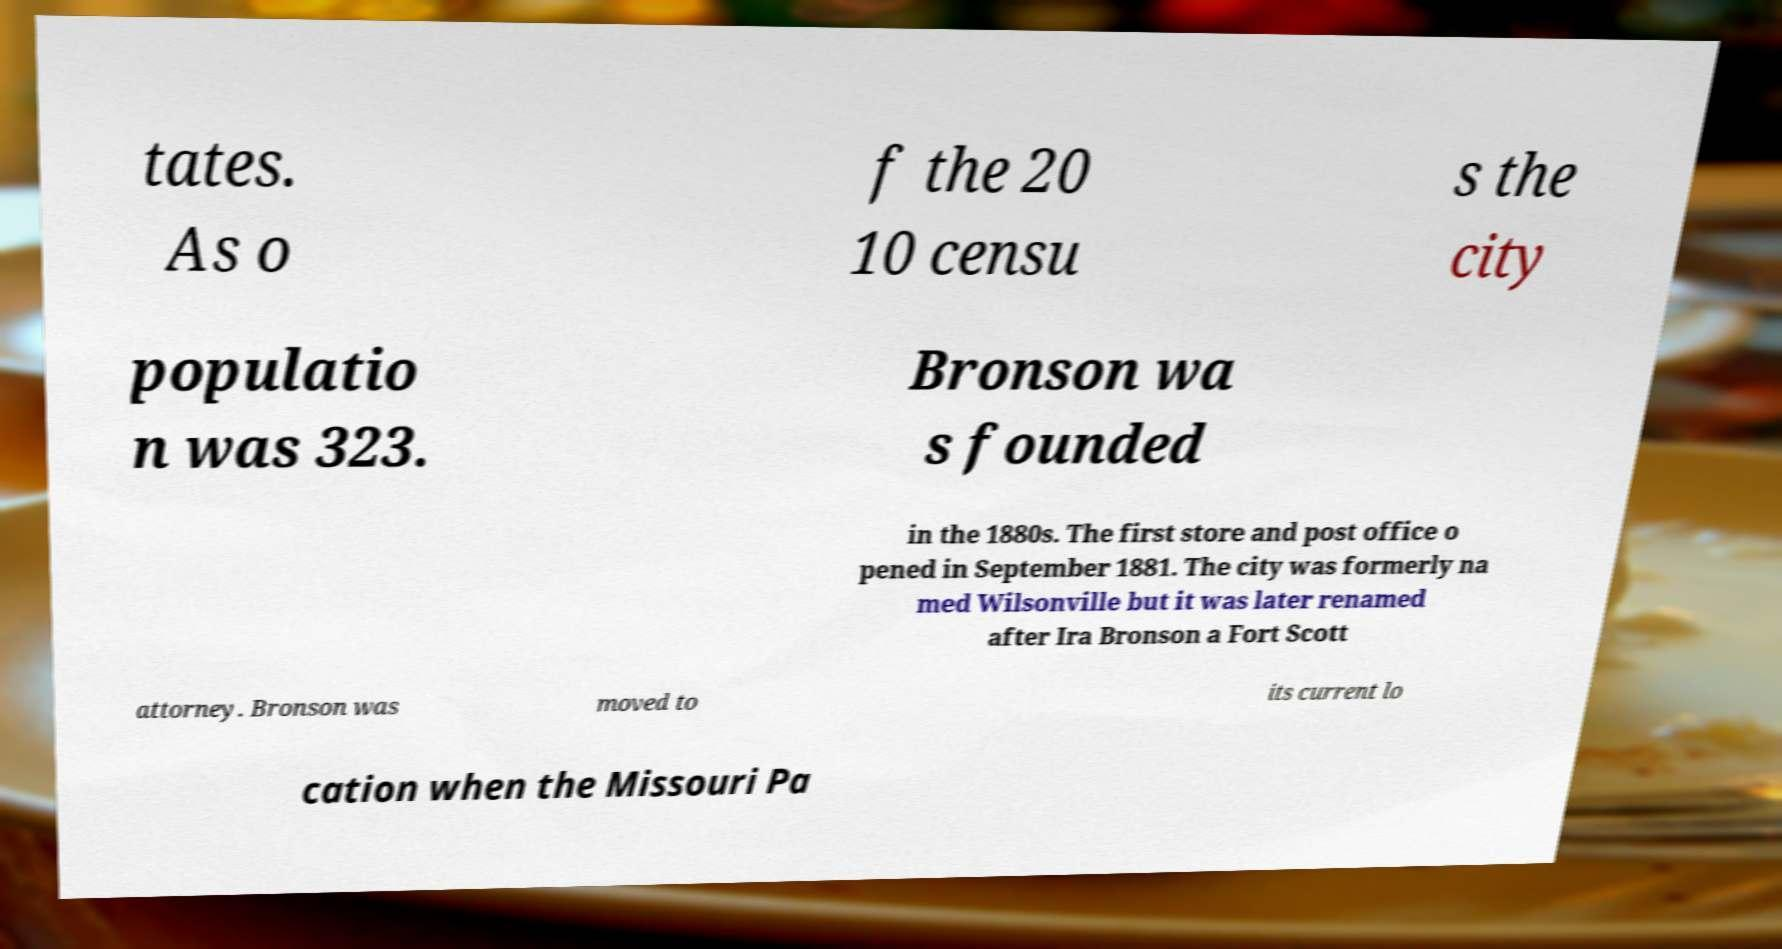Please identify and transcribe the text found in this image. tates. As o f the 20 10 censu s the city populatio n was 323. Bronson wa s founded in the 1880s. The first store and post office o pened in September 1881. The city was formerly na med Wilsonville but it was later renamed after Ira Bronson a Fort Scott attorney. Bronson was moved to its current lo cation when the Missouri Pa 